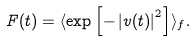Convert formula to latex. <formula><loc_0><loc_0><loc_500><loc_500>F ( t ) = \langle \exp \left [ - \left | v ( t ) \right | ^ { 2 } \right ] \rangle _ { f } .</formula> 